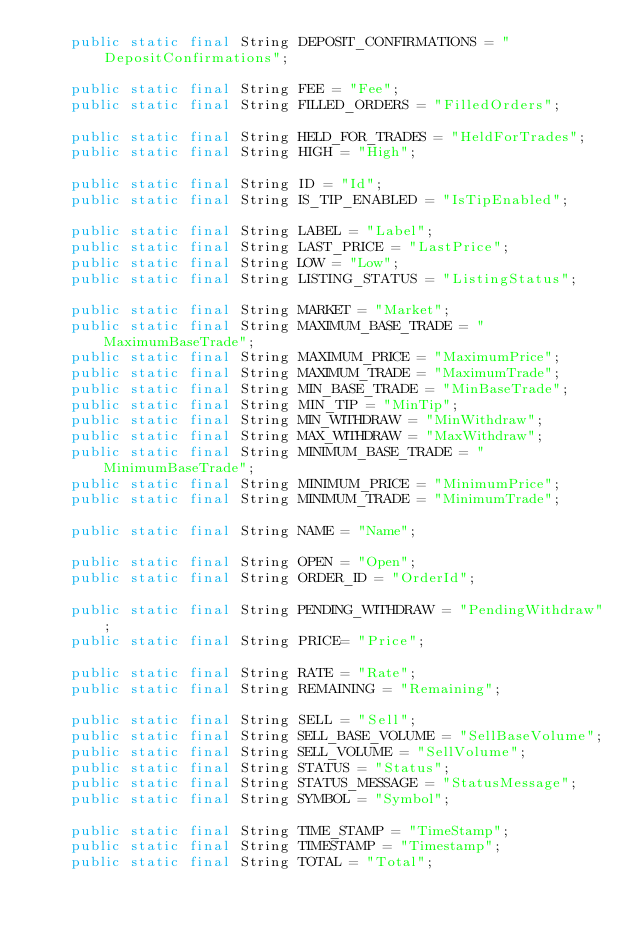<code> <loc_0><loc_0><loc_500><loc_500><_Java_>    public static final String DEPOSIT_CONFIRMATIONS = "DepositConfirmations";

    public static final String FEE = "Fee";
    public static final String FILLED_ORDERS = "FilledOrders";

    public static final String HELD_FOR_TRADES = "HeldForTrades";
    public static final String HIGH = "High";

    public static final String ID = "Id";
    public static final String IS_TIP_ENABLED = "IsTipEnabled";

    public static final String LABEL = "Label";
    public static final String LAST_PRICE = "LastPrice";
    public static final String LOW = "Low";
    public static final String LISTING_STATUS = "ListingStatus";

    public static final String MARKET = "Market";
    public static final String MAXIMUM_BASE_TRADE = "MaximumBaseTrade";
    public static final String MAXIMUM_PRICE = "MaximumPrice";
    public static final String MAXIMUM_TRADE = "MaximumTrade";
    public static final String MIN_BASE_TRADE = "MinBaseTrade";
    public static final String MIN_TIP = "MinTip";
    public static final String MIN_WITHDRAW = "MinWithdraw";
    public static final String MAX_WITHDRAW = "MaxWithdraw";
    public static final String MINIMUM_BASE_TRADE = "MinimumBaseTrade";
    public static final String MINIMUM_PRICE = "MinimumPrice";
    public static final String MINIMUM_TRADE = "MinimumTrade";

    public static final String NAME = "Name";

    public static final String OPEN = "Open";
    public static final String ORDER_ID = "OrderId";

    public static final String PENDING_WITHDRAW = "PendingWithdraw";
    public static final String PRICE= "Price";

    public static final String RATE = "Rate";
    public static final String REMAINING = "Remaining";

    public static final String SELL = "Sell";
    public static final String SELL_BASE_VOLUME = "SellBaseVolume";
    public static final String SELL_VOLUME = "SellVolume";
    public static final String STATUS = "Status";
    public static final String STATUS_MESSAGE = "StatusMessage";
    public static final String SYMBOL = "Symbol";

    public static final String TIME_STAMP = "TimeStamp";
    public static final String TIMESTAMP = "Timestamp";
    public static final String TOTAL = "Total";</code> 